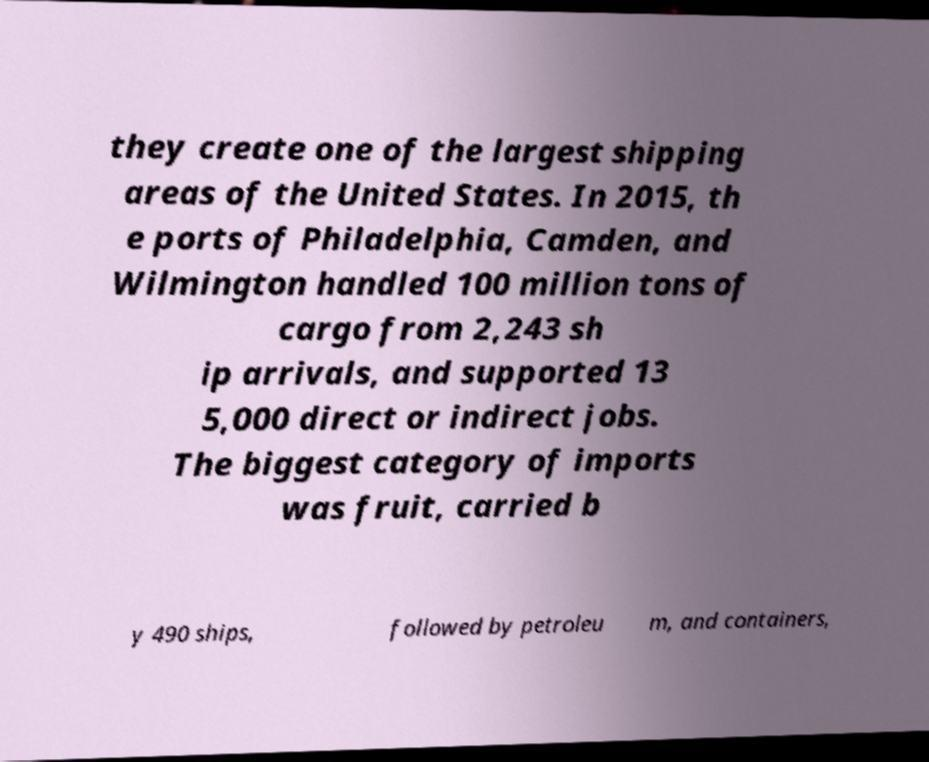Please identify and transcribe the text found in this image. they create one of the largest shipping areas of the United States. In 2015, th e ports of Philadelphia, Camden, and Wilmington handled 100 million tons of cargo from 2,243 sh ip arrivals, and supported 13 5,000 direct or indirect jobs. The biggest category of imports was fruit, carried b y 490 ships, followed by petroleu m, and containers, 